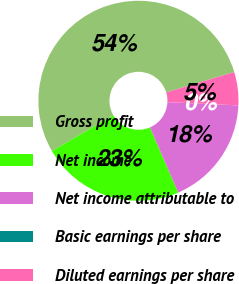Convert chart to OTSL. <chart><loc_0><loc_0><loc_500><loc_500><pie_chart><fcel>Gross profit<fcel>Net income<fcel>Net income attributable to<fcel>Basic earnings per share<fcel>Diluted earnings per share<nl><fcel>53.74%<fcel>23.13%<fcel>17.76%<fcel>0.0%<fcel>5.37%<nl></chart> 